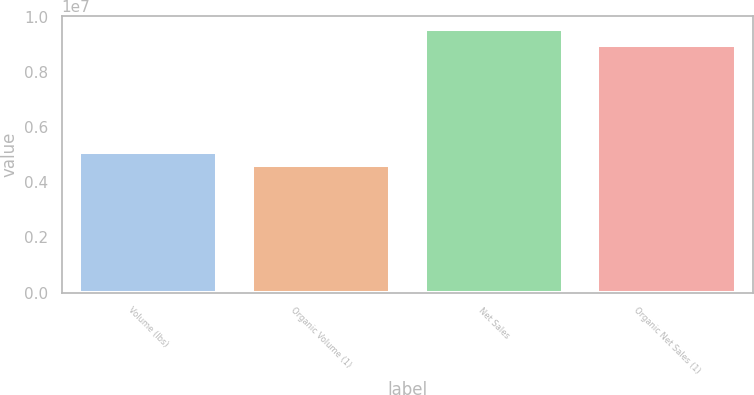Convert chart. <chart><loc_0><loc_0><loc_500><loc_500><bar_chart><fcel>Volume (lbs)<fcel>Organic Volume (1)<fcel>Net Sales<fcel>Organic Net Sales (1)<nl><fcel>5.11452e+06<fcel>4.62217e+06<fcel>9.5457e+06<fcel>8.98484e+06<nl></chart> 